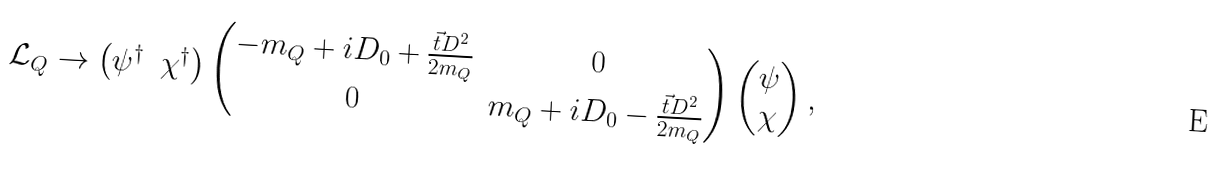Convert formula to latex. <formula><loc_0><loc_0><loc_500><loc_500>\mathcal { L } _ { Q } \rightarrow \begin{pmatrix} \psi ^ { \dag } & \chi ^ { \dag } \end{pmatrix} \begin{pmatrix} - m _ { Q } + i D _ { 0 } + \frac { \vec { t } { D } ^ { 2 } } { 2 m _ { Q } } & 0 \\ 0 & m _ { Q } + i D _ { 0 } - \frac { \vec { t } { D } ^ { 2 } } { 2 m _ { Q } } \end{pmatrix} \begin{pmatrix} \psi \\ \chi \end{pmatrix} ,</formula> 